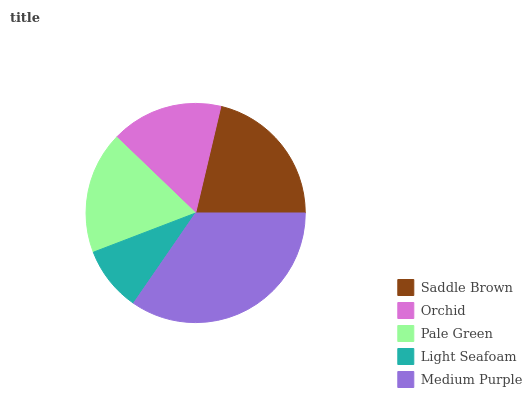Is Light Seafoam the minimum?
Answer yes or no. Yes. Is Medium Purple the maximum?
Answer yes or no. Yes. Is Orchid the minimum?
Answer yes or no. No. Is Orchid the maximum?
Answer yes or no. No. Is Saddle Brown greater than Orchid?
Answer yes or no. Yes. Is Orchid less than Saddle Brown?
Answer yes or no. Yes. Is Orchid greater than Saddle Brown?
Answer yes or no. No. Is Saddle Brown less than Orchid?
Answer yes or no. No. Is Pale Green the high median?
Answer yes or no. Yes. Is Pale Green the low median?
Answer yes or no. Yes. Is Orchid the high median?
Answer yes or no. No. Is Orchid the low median?
Answer yes or no. No. 